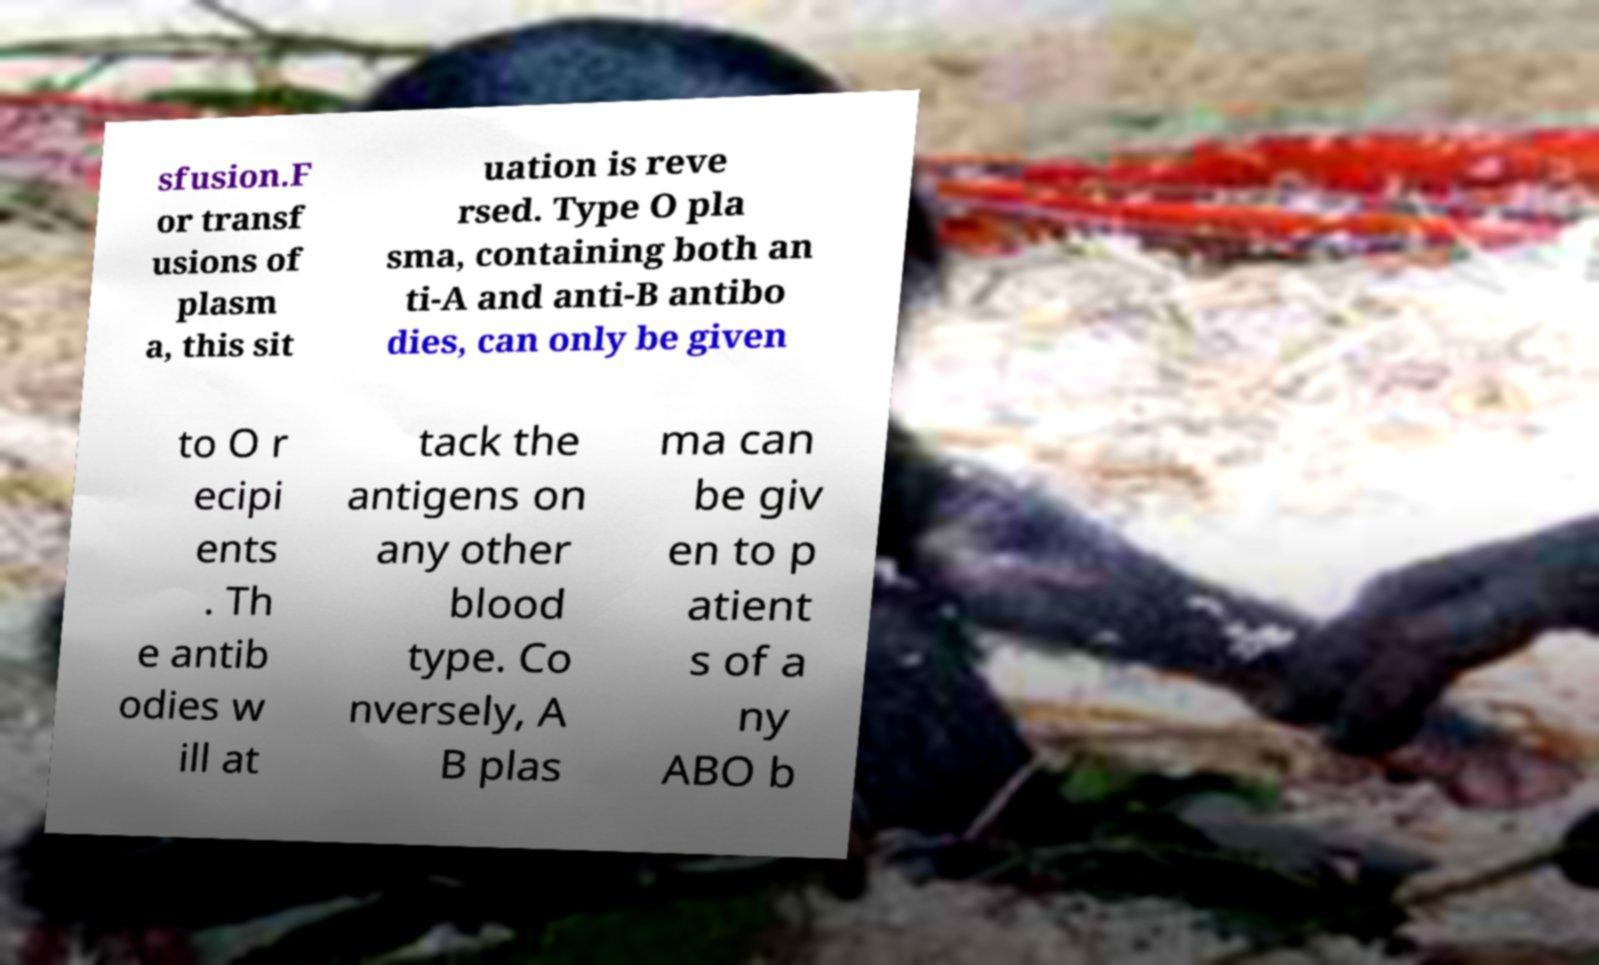Can you read and provide the text displayed in the image?This photo seems to have some interesting text. Can you extract and type it out for me? sfusion.F or transf usions of plasm a, this sit uation is reve rsed. Type O pla sma, containing both an ti-A and anti-B antibo dies, can only be given to O r ecipi ents . Th e antib odies w ill at tack the antigens on any other blood type. Co nversely, A B plas ma can be giv en to p atient s of a ny ABO b 